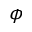<formula> <loc_0><loc_0><loc_500><loc_500>\phi</formula> 